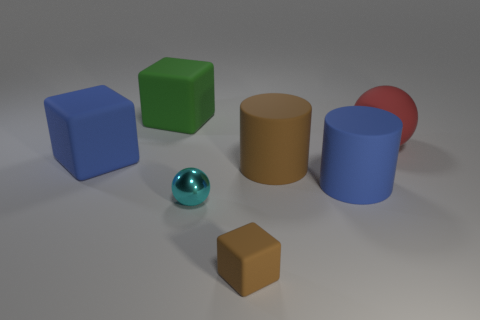There is a matte block that is both in front of the big matte ball and to the left of the tiny cyan metal ball; what color is it?
Your response must be concise. Blue. There is a blue matte thing behind the brown rubber cylinder; is it the same size as the big red rubber sphere?
Provide a succinct answer. Yes. Are there more blue objects on the right side of the brown cylinder than cyan objects?
Your answer should be very brief. No. Do the cyan thing and the red object have the same shape?
Make the answer very short. Yes. The brown block is what size?
Offer a very short reply. Small. Is the number of blue rubber cylinders to the left of the small brown cube greater than the number of things in front of the matte ball?
Give a very brief answer. No. Are there any cyan shiny balls behind the small metal sphere?
Give a very brief answer. No. Is there a shiny sphere of the same size as the red rubber ball?
Keep it short and to the point. No. What color is the large sphere that is made of the same material as the blue cube?
Make the answer very short. Red. What is the material of the green thing?
Your answer should be compact. Rubber. 